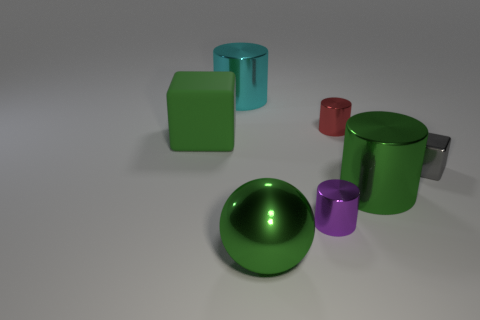Add 3 metallic objects. How many objects exist? 10 Subtract all yellow cylinders. Subtract all yellow spheres. How many cylinders are left? 4 Subtract all cubes. How many objects are left? 5 Subtract all big green cubes. Subtract all large cyan cylinders. How many objects are left? 5 Add 6 spheres. How many spheres are left? 7 Add 3 yellow matte things. How many yellow matte things exist? 3 Subtract 1 gray cubes. How many objects are left? 6 